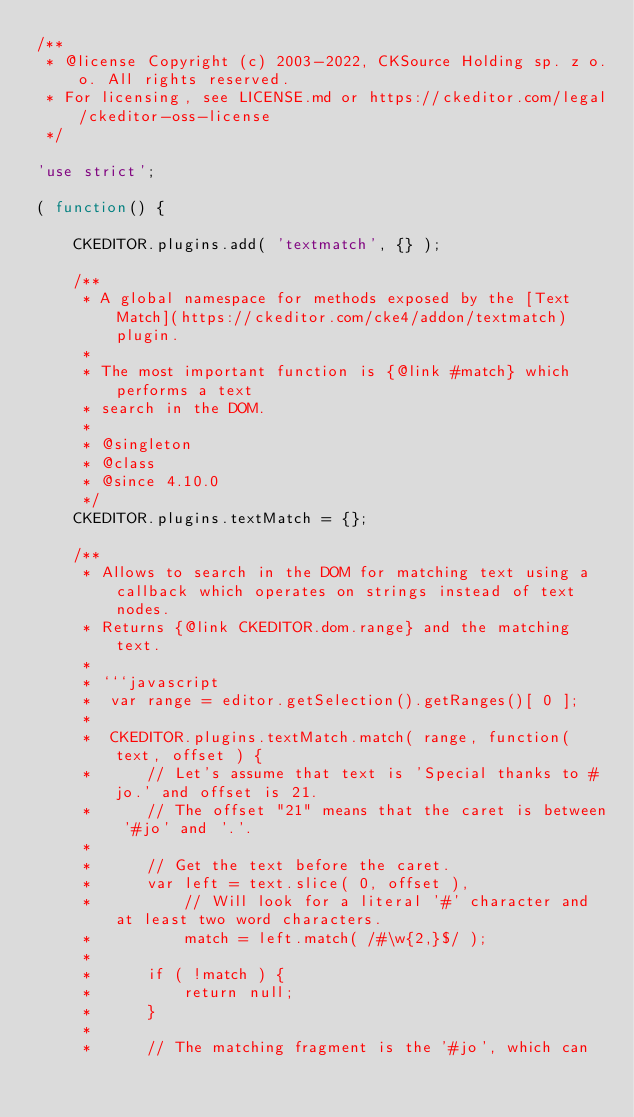<code> <loc_0><loc_0><loc_500><loc_500><_JavaScript_>/**
 * @license Copyright (c) 2003-2022, CKSource Holding sp. z o.o. All rights reserved.
 * For licensing, see LICENSE.md or https://ckeditor.com/legal/ckeditor-oss-license
 */

'use strict';

( function() {

	CKEDITOR.plugins.add( 'textmatch', {} );

	/**
	 * A global namespace for methods exposed by the [Text Match](https://ckeditor.com/cke4/addon/textmatch) plugin.
	 *
	 * The most important function is {@link #match} which performs a text
	 * search in the DOM.
	 *
	 * @singleton
	 * @class
	 * @since 4.10.0
	 */
	CKEDITOR.plugins.textMatch = {};

	/**
	 * Allows to search in the DOM for matching text using a callback which operates on strings instead of text nodes.
	 * Returns {@link CKEDITOR.dom.range} and the matching text.
	 *
	 * ```javascript
	 *	var range = editor.getSelection().getRanges()[ 0 ];
	 *
	 *	CKEDITOR.plugins.textMatch.match( range, function( text, offset ) {
	 *		// Let's assume that text is 'Special thanks to #jo.' and offset is 21.
	 *		// The offset "21" means that the caret is between '#jo' and '.'.
	 *
	 *		// Get the text before the caret.
	 *		var left = text.slice( 0, offset ),
	 *			// Will look for a literal '#' character and at least two word characters.
	 *			match = left.match( /#\w{2,}$/ );
	 *
	 *		if ( !match ) {
	 *			return null;
	 *		}
	 *
	 *		// The matching fragment is the '#jo', which can</code> 